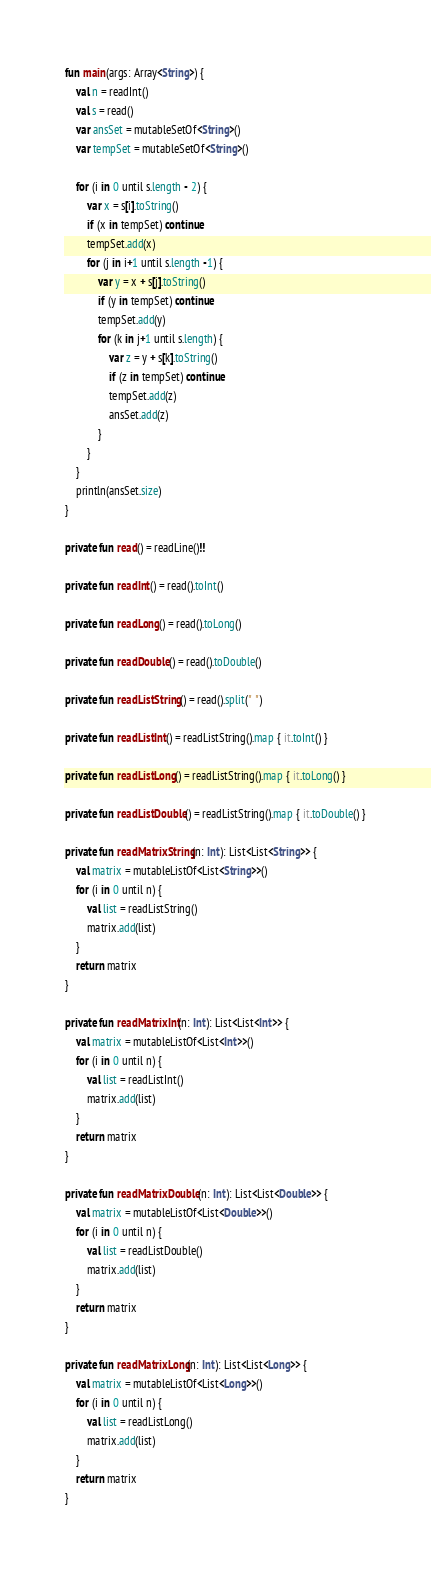<code> <loc_0><loc_0><loc_500><loc_500><_Kotlin_>fun main(args: Array<String>) {
    val n = readInt()
    val s = read()
    var ansSet = mutableSetOf<String>()
    var tempSet = mutableSetOf<String>()

    for (i in 0 until s.length - 2) {
        var x = s[i].toString()
        if (x in tempSet) continue
        tempSet.add(x)
        for (j in i+1 until s.length -1) {
            var y = x + s[j].toString()
            if (y in tempSet) continue
            tempSet.add(y)
            for (k in j+1 until s.length) {
                var z = y + s[k].toString()
                if (z in tempSet) continue
                tempSet.add(z)
                ansSet.add(z)
            }
        }
    }
    println(ansSet.size)
}

private fun read() = readLine()!!

private fun readInt() = read().toInt()

private fun readLong() = read().toLong()

private fun readDouble() = read().toDouble()

private fun readListString() = read().split(" ")

private fun readListInt() = readListString().map { it.toInt() }

private fun readListLong() = readListString().map { it.toLong() }

private fun readListDouble() = readListString().map { it.toDouble() }

private fun readMatrixString(n: Int): List<List<String>> {
    val matrix = mutableListOf<List<String>>()
    for (i in 0 until n) {
        val list = readListString()
        matrix.add(list)
    }
    return matrix
}

private fun readMatrixInt(n: Int): List<List<Int>> {
    val matrix = mutableListOf<List<Int>>()
    for (i in 0 until n) {
        val list = readListInt()
        matrix.add(list)
    }
    return matrix
}

private fun readMatrixDouble(n: Int): List<List<Double>> {
    val matrix = mutableListOf<List<Double>>()
    for (i in 0 until n) {
        val list = readListDouble()
        matrix.add(list)
    }
    return matrix
}

private fun readMatrixLong(n: Int): List<List<Long>> {
    val matrix = mutableListOf<List<Long>>()
    for (i in 0 until n) {
        val list = readListLong()
        matrix.add(list)
    }
    return matrix
}

</code> 